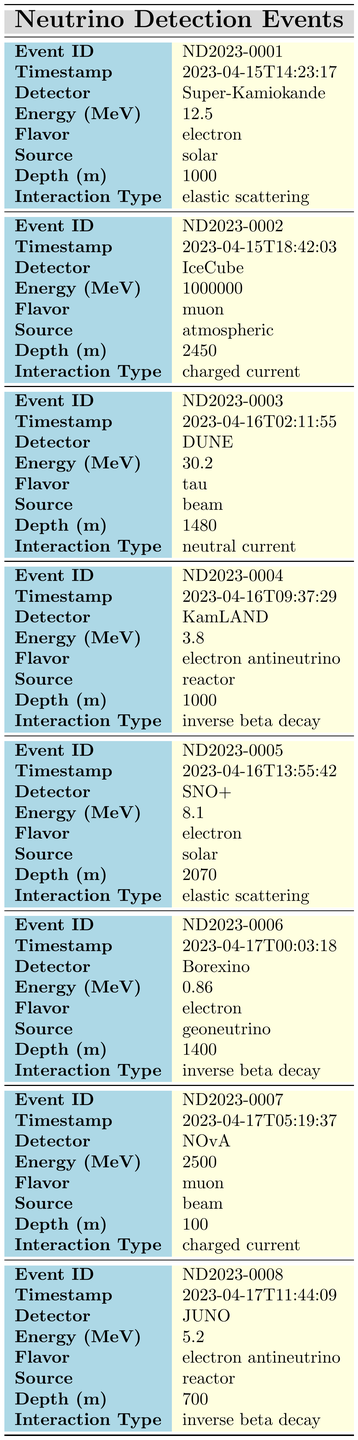What is the energy level of the event recorded by the IceCube detector? According to the table, for the IceCube event (ND2023-0002), the energy is listed as 1000000 MeV.
Answer: 1000000 MeV How many events had an energy measurement under 10 MeV? Looking at the energy values recorded, the events with energies 3.8 MeV (ND2023-0004), 0.86 MeV (ND2023-0006), and 5.2 MeV (ND2023-0008) all fall under 10 MeV. Thus, there are 3 events with energy below 10 MeV.
Answer: 3 What is the maximum depth at which a neutrino detection event was recorded? By reviewing the depths in the table, the maximum value is 2450 meters, recorded by the IceCube detector (ND2023-0002).
Answer: 2450 meters Is there an event from the solar source that involves electron flavor? The table indicates that there are two such events: ND2023-0001 (energy 12.5 MeV) and ND2023-0005 (energy 8.1 MeV) both from solar sources with electron flavor. Therefore, the statement is true.
Answer: Yes How many events were recorded using charged current interaction, and what are their energy values? From the table, the events involving charged current interaction are ND2023-0002 (1000000 MeV) and ND2023-0007 (2500 MeV). Thus, there are 2 such events, with energies 1000000 MeV and 2500 MeV.
Answer: 2 events; 1000000 MeV and 2500 MeV Which detector recorded the lowest energy event and what was the energy? The lowest energy event was detected by Borexino (ND2023-0006), recording an energy of 0.86 MeV.
Answer: Borexino; 0.86 MeV What proportion of events were from reactor sources? There are a total of 8 events and 3 of them are from reactor sources (ND2023-0004, ND2023-0008). Calculating the proportion: 3/8 = 0.375.
Answer: 0.375 If you average the energies from the solar events, what would this yield? The solar events listed are ND2023-0001 (12.5 MeV) and ND2023-0005 (8.1 MeV). Adding these gives 20.6 MeV, and averaging over 2 events yields 20.6/2 = 10.3 MeV.
Answer: 10.3 MeV How does the number of muon flavor events compare to the number of electron antineutrino events? There are 2 muon events (ND2023-0002, ND2023-0007) and 2 electron antineutrino events (ND2023-0004, ND2023-0008). Therefore, the count is the same.
Answer: They are equal; 2 events each 